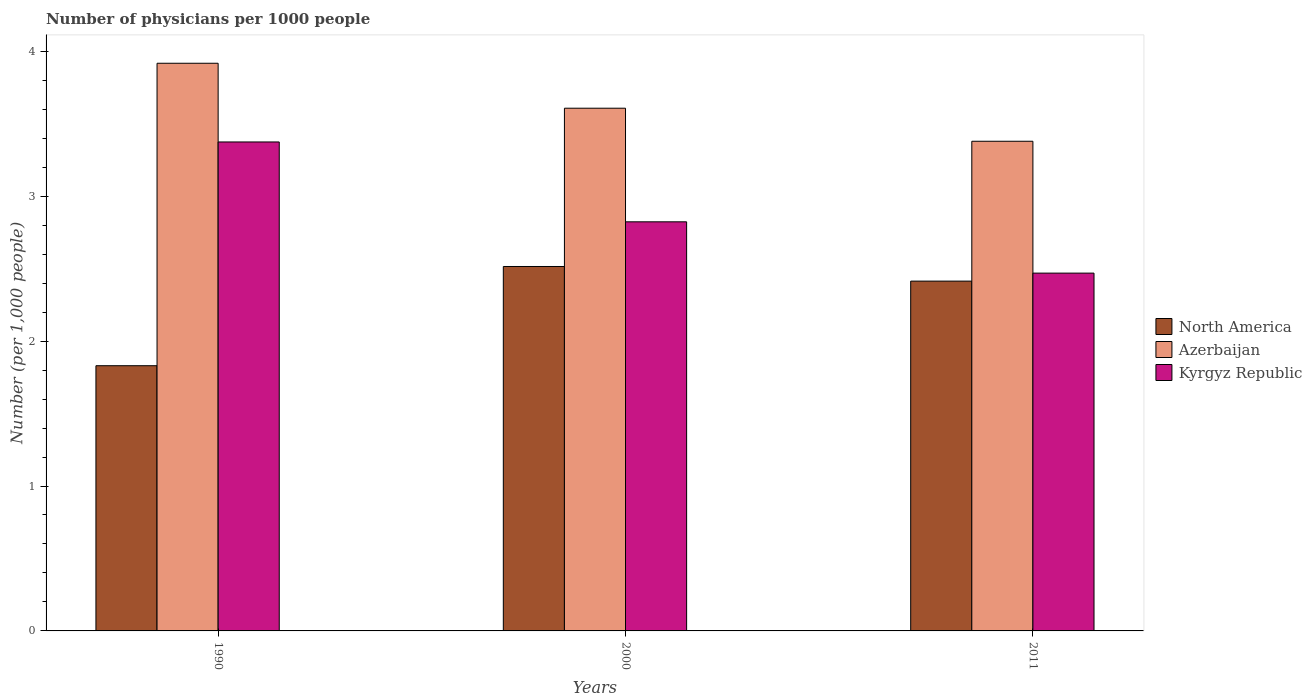How many groups of bars are there?
Offer a terse response. 3. How many bars are there on the 1st tick from the left?
Give a very brief answer. 3. How many bars are there on the 2nd tick from the right?
Your answer should be very brief. 3. In how many cases, is the number of bars for a given year not equal to the number of legend labels?
Your response must be concise. 0. What is the number of physicians in North America in 1990?
Ensure brevity in your answer.  1.83. Across all years, what is the maximum number of physicians in Azerbaijan?
Keep it short and to the point. 3.92. Across all years, what is the minimum number of physicians in Kyrgyz Republic?
Give a very brief answer. 2.47. What is the total number of physicians in Azerbaijan in the graph?
Provide a short and direct response. 10.9. What is the difference between the number of physicians in Kyrgyz Republic in 1990 and that in 2011?
Your answer should be compact. 0.91. What is the difference between the number of physicians in Azerbaijan in 2011 and the number of physicians in Kyrgyz Republic in 2000?
Offer a terse response. 0.56. What is the average number of physicians in Azerbaijan per year?
Provide a short and direct response. 3.63. In the year 2011, what is the difference between the number of physicians in North America and number of physicians in Azerbaijan?
Provide a short and direct response. -0.97. What is the ratio of the number of physicians in North America in 2000 to that in 2011?
Give a very brief answer. 1.04. Is the number of physicians in Azerbaijan in 2000 less than that in 2011?
Your response must be concise. No. What is the difference between the highest and the second highest number of physicians in Azerbaijan?
Provide a succinct answer. 0.31. What is the difference between the highest and the lowest number of physicians in Kyrgyz Republic?
Keep it short and to the point. 0.91. What does the 3rd bar from the left in 2000 represents?
Keep it short and to the point. Kyrgyz Republic. What does the 3rd bar from the right in 2000 represents?
Make the answer very short. North America. How many years are there in the graph?
Your answer should be very brief. 3. What is the difference between two consecutive major ticks on the Y-axis?
Ensure brevity in your answer.  1. Are the values on the major ticks of Y-axis written in scientific E-notation?
Provide a succinct answer. No. Does the graph contain any zero values?
Provide a short and direct response. No. Does the graph contain grids?
Make the answer very short. No. What is the title of the graph?
Provide a succinct answer. Number of physicians per 1000 people. Does "Aruba" appear as one of the legend labels in the graph?
Ensure brevity in your answer.  No. What is the label or title of the X-axis?
Offer a very short reply. Years. What is the label or title of the Y-axis?
Give a very brief answer. Number (per 1,0 people). What is the Number (per 1,000 people) in North America in 1990?
Your response must be concise. 1.83. What is the Number (per 1,000 people) of Azerbaijan in 1990?
Offer a terse response. 3.92. What is the Number (per 1,000 people) in Kyrgyz Republic in 1990?
Ensure brevity in your answer.  3.37. What is the Number (per 1,000 people) in North America in 2000?
Offer a very short reply. 2.51. What is the Number (per 1,000 people) of Azerbaijan in 2000?
Provide a succinct answer. 3.61. What is the Number (per 1,000 people) in Kyrgyz Republic in 2000?
Offer a very short reply. 2.82. What is the Number (per 1,000 people) in North America in 2011?
Provide a succinct answer. 2.41. What is the Number (per 1,000 people) of Azerbaijan in 2011?
Offer a very short reply. 3.38. What is the Number (per 1,000 people) of Kyrgyz Republic in 2011?
Provide a succinct answer. 2.47. Across all years, what is the maximum Number (per 1,000 people) in North America?
Your answer should be compact. 2.51. Across all years, what is the maximum Number (per 1,000 people) of Azerbaijan?
Your answer should be compact. 3.92. Across all years, what is the maximum Number (per 1,000 people) in Kyrgyz Republic?
Offer a terse response. 3.37. Across all years, what is the minimum Number (per 1,000 people) of North America?
Your answer should be compact. 1.83. Across all years, what is the minimum Number (per 1,000 people) in Azerbaijan?
Your answer should be compact. 3.38. Across all years, what is the minimum Number (per 1,000 people) in Kyrgyz Republic?
Your answer should be very brief. 2.47. What is the total Number (per 1,000 people) of North America in the graph?
Your answer should be compact. 6.76. What is the total Number (per 1,000 people) in Azerbaijan in the graph?
Offer a very short reply. 10.9. What is the total Number (per 1,000 people) of Kyrgyz Republic in the graph?
Your answer should be very brief. 8.67. What is the difference between the Number (per 1,000 people) of North America in 1990 and that in 2000?
Provide a succinct answer. -0.68. What is the difference between the Number (per 1,000 people) in Azerbaijan in 1990 and that in 2000?
Ensure brevity in your answer.  0.31. What is the difference between the Number (per 1,000 people) in Kyrgyz Republic in 1990 and that in 2000?
Make the answer very short. 0.55. What is the difference between the Number (per 1,000 people) of North America in 1990 and that in 2011?
Your answer should be compact. -0.58. What is the difference between the Number (per 1,000 people) of Azerbaijan in 1990 and that in 2011?
Give a very brief answer. 0.54. What is the difference between the Number (per 1,000 people) of Kyrgyz Republic in 1990 and that in 2011?
Ensure brevity in your answer.  0.91. What is the difference between the Number (per 1,000 people) of North America in 2000 and that in 2011?
Give a very brief answer. 0.1. What is the difference between the Number (per 1,000 people) of Azerbaijan in 2000 and that in 2011?
Make the answer very short. 0.23. What is the difference between the Number (per 1,000 people) of Kyrgyz Republic in 2000 and that in 2011?
Provide a succinct answer. 0.35. What is the difference between the Number (per 1,000 people) of North America in 1990 and the Number (per 1,000 people) of Azerbaijan in 2000?
Give a very brief answer. -1.78. What is the difference between the Number (per 1,000 people) in North America in 1990 and the Number (per 1,000 people) in Kyrgyz Republic in 2000?
Give a very brief answer. -0.99. What is the difference between the Number (per 1,000 people) of Azerbaijan in 1990 and the Number (per 1,000 people) of Kyrgyz Republic in 2000?
Provide a succinct answer. 1.09. What is the difference between the Number (per 1,000 people) of North America in 1990 and the Number (per 1,000 people) of Azerbaijan in 2011?
Keep it short and to the point. -1.55. What is the difference between the Number (per 1,000 people) in North America in 1990 and the Number (per 1,000 people) in Kyrgyz Republic in 2011?
Offer a very short reply. -0.64. What is the difference between the Number (per 1,000 people) of Azerbaijan in 1990 and the Number (per 1,000 people) of Kyrgyz Republic in 2011?
Your response must be concise. 1.45. What is the difference between the Number (per 1,000 people) of North America in 2000 and the Number (per 1,000 people) of Azerbaijan in 2011?
Your answer should be compact. -0.86. What is the difference between the Number (per 1,000 people) of North America in 2000 and the Number (per 1,000 people) of Kyrgyz Republic in 2011?
Provide a succinct answer. 0.05. What is the difference between the Number (per 1,000 people) in Azerbaijan in 2000 and the Number (per 1,000 people) in Kyrgyz Republic in 2011?
Make the answer very short. 1.14. What is the average Number (per 1,000 people) in North America per year?
Offer a terse response. 2.25. What is the average Number (per 1,000 people) of Azerbaijan per year?
Ensure brevity in your answer.  3.63. What is the average Number (per 1,000 people) in Kyrgyz Republic per year?
Give a very brief answer. 2.89. In the year 1990, what is the difference between the Number (per 1,000 people) of North America and Number (per 1,000 people) of Azerbaijan?
Provide a succinct answer. -2.09. In the year 1990, what is the difference between the Number (per 1,000 people) in North America and Number (per 1,000 people) in Kyrgyz Republic?
Provide a succinct answer. -1.54. In the year 1990, what is the difference between the Number (per 1,000 people) in Azerbaijan and Number (per 1,000 people) in Kyrgyz Republic?
Provide a short and direct response. 0.54. In the year 2000, what is the difference between the Number (per 1,000 people) of North America and Number (per 1,000 people) of Azerbaijan?
Give a very brief answer. -1.09. In the year 2000, what is the difference between the Number (per 1,000 people) of North America and Number (per 1,000 people) of Kyrgyz Republic?
Ensure brevity in your answer.  -0.31. In the year 2000, what is the difference between the Number (per 1,000 people) of Azerbaijan and Number (per 1,000 people) of Kyrgyz Republic?
Keep it short and to the point. 0.78. In the year 2011, what is the difference between the Number (per 1,000 people) of North America and Number (per 1,000 people) of Azerbaijan?
Provide a succinct answer. -0.97. In the year 2011, what is the difference between the Number (per 1,000 people) in North America and Number (per 1,000 people) in Kyrgyz Republic?
Your response must be concise. -0.06. In the year 2011, what is the difference between the Number (per 1,000 people) of Azerbaijan and Number (per 1,000 people) of Kyrgyz Republic?
Keep it short and to the point. 0.91. What is the ratio of the Number (per 1,000 people) in North America in 1990 to that in 2000?
Ensure brevity in your answer.  0.73. What is the ratio of the Number (per 1,000 people) of Azerbaijan in 1990 to that in 2000?
Offer a terse response. 1.09. What is the ratio of the Number (per 1,000 people) in Kyrgyz Republic in 1990 to that in 2000?
Provide a succinct answer. 1.2. What is the ratio of the Number (per 1,000 people) of North America in 1990 to that in 2011?
Provide a short and direct response. 0.76. What is the ratio of the Number (per 1,000 people) of Azerbaijan in 1990 to that in 2011?
Provide a short and direct response. 1.16. What is the ratio of the Number (per 1,000 people) in Kyrgyz Republic in 1990 to that in 2011?
Your answer should be compact. 1.37. What is the ratio of the Number (per 1,000 people) of North America in 2000 to that in 2011?
Provide a succinct answer. 1.04. What is the ratio of the Number (per 1,000 people) of Azerbaijan in 2000 to that in 2011?
Offer a very short reply. 1.07. What is the ratio of the Number (per 1,000 people) of Kyrgyz Republic in 2000 to that in 2011?
Your answer should be very brief. 1.14. What is the difference between the highest and the second highest Number (per 1,000 people) in North America?
Keep it short and to the point. 0.1. What is the difference between the highest and the second highest Number (per 1,000 people) of Azerbaijan?
Your response must be concise. 0.31. What is the difference between the highest and the second highest Number (per 1,000 people) in Kyrgyz Republic?
Offer a very short reply. 0.55. What is the difference between the highest and the lowest Number (per 1,000 people) in North America?
Ensure brevity in your answer.  0.68. What is the difference between the highest and the lowest Number (per 1,000 people) of Azerbaijan?
Offer a terse response. 0.54. What is the difference between the highest and the lowest Number (per 1,000 people) in Kyrgyz Republic?
Ensure brevity in your answer.  0.91. 